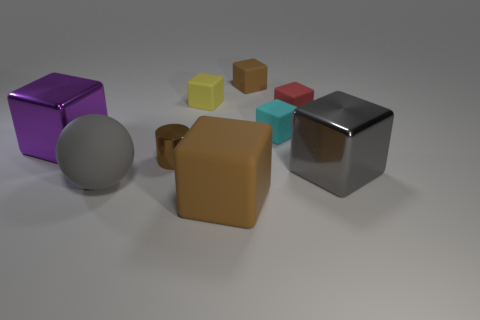How do the objects in the image appear in terms of their material composition? The objects in the image display a variety of material compositions. The shininess of the cylinders and one cube suggests they could be metallic, whereas the matte surface of the brown and yellow cubes, as well as one sphere, implies a more rubber-like quality, demonstrating a diverse mix of textures and materials. 